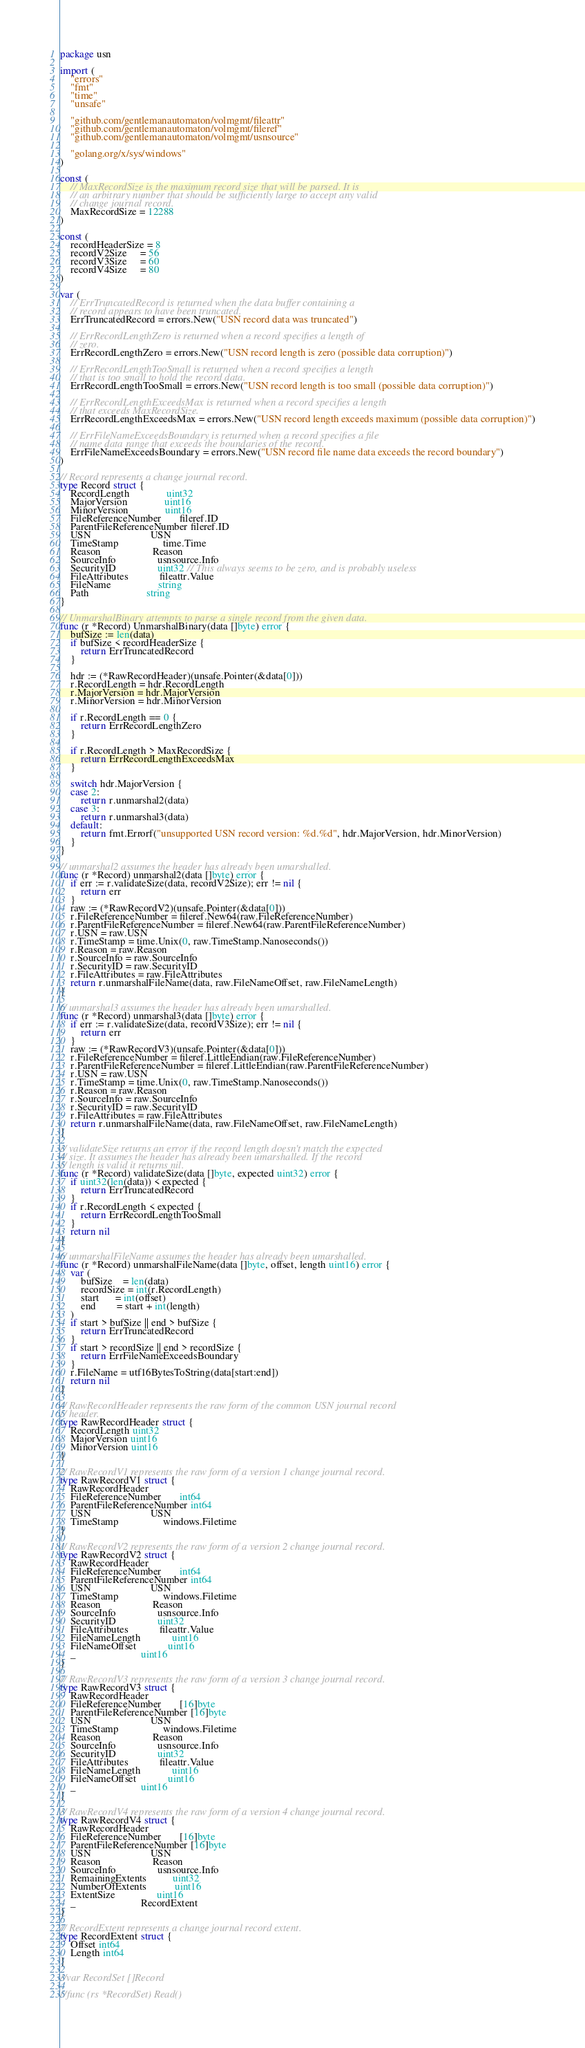<code> <loc_0><loc_0><loc_500><loc_500><_Go_>package usn

import (
	"errors"
	"fmt"
	"time"
	"unsafe"

	"github.com/gentlemanautomaton/volmgmt/fileattr"
	"github.com/gentlemanautomaton/volmgmt/fileref"
	"github.com/gentlemanautomaton/volmgmt/usnsource"

	"golang.org/x/sys/windows"
)

const (
	// MaxRecordSize is the maximum record size that will be parsed. It is
	// an arbitrary number that should be sufficiently large to accept any valid
	// change journal record.
	MaxRecordSize = 12288
)

const (
	recordHeaderSize = 8
	recordV2Size     = 56
	recordV3Size     = 60
	recordV4Size     = 80
)

var (
	// ErrTruncatedRecord is returned when the data buffer containing a
	// record appears to have been truncated.
	ErrTruncatedRecord = errors.New("USN record data was truncated")

	// ErrRecordLengthZero is returned when a record specifies a length of
	// zero.
	ErrRecordLengthZero = errors.New("USN record length is zero (possible data corruption)")

	// ErrRecordLengthTooSmall is returned when a record specifies a length
	// that is too small to hold the record data.
	ErrRecordLengthTooSmall = errors.New("USN record length is too small (possible data corruption)")

	// ErrRecordLengthExceedsMax is returned when a record specifies a length
	// that exceeds MaxRecordSize.
	ErrRecordLengthExceedsMax = errors.New("USN record length exceeds maximum (possible data corruption)")

	// ErrFileNameExceedsBoundary is returned when a record specifies a file
	// name data range that exceeds the boundaries of the record.
	ErrFileNameExceedsBoundary = errors.New("USN record file name data exceeds the record boundary")
)

// Record represents a change journal record.
type Record struct {
	RecordLength              uint32
	MajorVersion              uint16
	MinorVersion              uint16
	FileReferenceNumber       fileref.ID
	ParentFileReferenceNumber fileref.ID
	USN                       USN
	TimeStamp                 time.Time
	Reason                    Reason
	SourceInfo                usnsource.Info
	SecurityID                uint32 // This always seems to be zero, and is probably useless
	FileAttributes            fileattr.Value
	FileName                  string
	Path                      string
}

// UnmarshalBinary attempts to parse a single record from the given data.
func (r *Record) UnmarshalBinary(data []byte) error {
	bufSize := len(data)
	if bufSize < recordHeaderSize {
		return ErrTruncatedRecord
	}

	hdr := (*RawRecordHeader)(unsafe.Pointer(&data[0]))
	r.RecordLength = hdr.RecordLength
	r.MajorVersion = hdr.MajorVersion
	r.MinorVersion = hdr.MinorVersion

	if r.RecordLength == 0 {
		return ErrRecordLengthZero
	}

	if r.RecordLength > MaxRecordSize {
		return ErrRecordLengthExceedsMax
	}

	switch hdr.MajorVersion {
	case 2:
		return r.unmarshal2(data)
	case 3:
		return r.unmarshal3(data)
	default:
		return fmt.Errorf("unsupported USN record version: %d.%d", hdr.MajorVersion, hdr.MinorVersion)
	}
}

// unmarshal2 assumes the header has already been umarshalled.
func (r *Record) unmarshal2(data []byte) error {
	if err := r.validateSize(data, recordV2Size); err != nil {
		return err
	}
	raw := (*RawRecordV2)(unsafe.Pointer(&data[0]))
	r.FileReferenceNumber = fileref.New64(raw.FileReferenceNumber)
	r.ParentFileReferenceNumber = fileref.New64(raw.ParentFileReferenceNumber)
	r.USN = raw.USN
	r.TimeStamp = time.Unix(0, raw.TimeStamp.Nanoseconds())
	r.Reason = raw.Reason
	r.SourceInfo = raw.SourceInfo
	r.SecurityID = raw.SecurityID
	r.FileAttributes = raw.FileAttributes
	return r.unmarshalFileName(data, raw.FileNameOffset, raw.FileNameLength)
}

// unmarshal3 assumes the header has already been umarshalled.
func (r *Record) unmarshal3(data []byte) error {
	if err := r.validateSize(data, recordV3Size); err != nil {
		return err
	}
	raw := (*RawRecordV3)(unsafe.Pointer(&data[0]))
	r.FileReferenceNumber = fileref.LittleEndian(raw.FileReferenceNumber)
	r.ParentFileReferenceNumber = fileref.LittleEndian(raw.ParentFileReferenceNumber)
	r.USN = raw.USN
	r.TimeStamp = time.Unix(0, raw.TimeStamp.Nanoseconds())
	r.Reason = raw.Reason
	r.SourceInfo = raw.SourceInfo
	r.SecurityID = raw.SecurityID
	r.FileAttributes = raw.FileAttributes
	return r.unmarshalFileName(data, raw.FileNameOffset, raw.FileNameLength)
}

// validateSize returns an error if the record length doesn't match the expected
// size. It assumes the header has already been umarshalled. If the record
// length is valid it returns nil.
func (r *Record) validateSize(data []byte, expected uint32) error {
	if uint32(len(data)) < expected {
		return ErrTruncatedRecord
	}
	if r.RecordLength < expected {
		return ErrRecordLengthTooSmall
	}
	return nil
}

// unmarshalFileName assumes the header has already been umarshalled.
func (r *Record) unmarshalFileName(data []byte, offset, length uint16) error {
	var (
		bufSize    = len(data)
		recordSize = int(r.RecordLength)
		start      = int(offset)
		end        = start + int(length)
	)
	if start > bufSize || end > bufSize {
		return ErrTruncatedRecord
	}
	if start > recordSize || end > recordSize {
		return ErrFileNameExceedsBoundary
	}
	r.FileName = utf16BytesToString(data[start:end])
	return nil
}

// RawRecordHeader represents the raw form of the common USN journal record
// header.
type RawRecordHeader struct {
	RecordLength uint32
	MajorVersion uint16
	MinorVersion uint16
}

// RawRecordV1 represents the raw form of a version 1 change journal record.
type RawRecordV1 struct {
	RawRecordHeader
	FileReferenceNumber       int64
	ParentFileReferenceNumber int64
	USN                       USN
	TimeStamp                 windows.Filetime
}

// RawRecordV2 represents the raw form of a version 2 change journal record.
type RawRecordV2 struct {
	RawRecordHeader
	FileReferenceNumber       int64
	ParentFileReferenceNumber int64
	USN                       USN
	TimeStamp                 windows.Filetime
	Reason                    Reason
	SourceInfo                usnsource.Info
	SecurityID                uint32
	FileAttributes            fileattr.Value
	FileNameLength            uint16
	FileNameOffset            uint16
	_                         uint16
}

// RawRecordV3 represents the raw form of a version 3 change journal record.
type RawRecordV3 struct {
	RawRecordHeader
	FileReferenceNumber       [16]byte
	ParentFileReferenceNumber [16]byte
	USN                       USN
	TimeStamp                 windows.Filetime
	Reason                    Reason
	SourceInfo                usnsource.Info
	SecurityID                uint32
	FileAttributes            fileattr.Value
	FileNameLength            uint16
	FileNameOffset            uint16
	_                         uint16
}

// RawRecordV4 represents the raw form of a version 4 change journal record.
type RawRecordV4 struct {
	RawRecordHeader
	FileReferenceNumber       [16]byte
	ParentFileReferenceNumber [16]byte
	USN                       USN
	Reason                    Reason
	SourceInfo                usnsource.Info
	RemainingExtents          uint32
	NumberOfExtents           uint16
	ExtentSize                uint16
	_                         RecordExtent
}

// RecordExtent represents a change journal record extent.
type RecordExtent struct {
	Offset int64
	Length int64
}

//var RecordSet []Record

//func (rs *RecordSet) Read()
</code> 